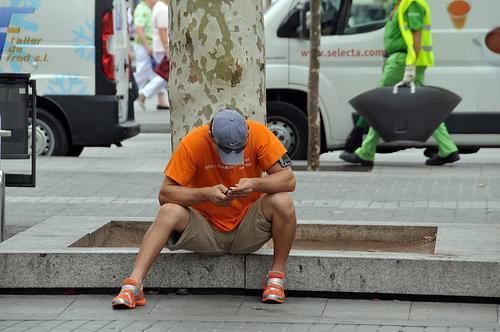What device is the one most probably attached to the man's arm?
Choose the right answer and clarify with the format: 'Answer: answer
Rationale: rationale.'
Options: Game, music player, phone, hard drive. Answer: music player.
Rationale: There is a man with a mp3 or something with headphones. 